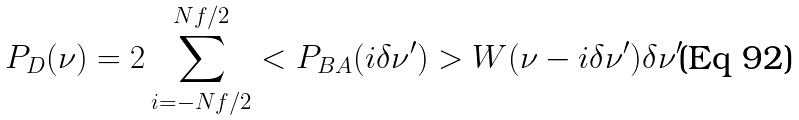Convert formula to latex. <formula><loc_0><loc_0><loc_500><loc_500>P _ { D } ( \nu ) = 2 \sum _ { i = - N f / 2 } ^ { N f / 2 } < P _ { B A } ( i \delta \nu ^ { \prime } ) > W ( \nu - i \delta \nu ^ { \prime } ) \delta \nu ^ { \prime }</formula> 